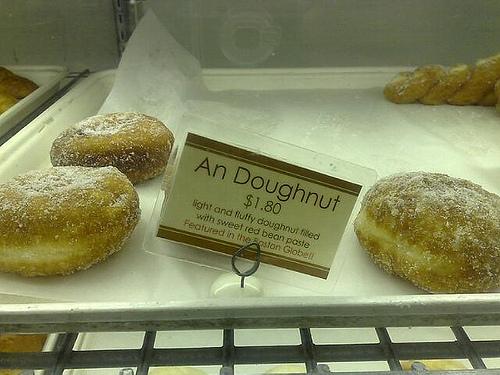How much do the donuts cost?
Give a very brief answer. $1.80. What language is the sign in front of the food items?
Give a very brief answer. English. How large are the donuts?
Answer briefly. Medium. Is this a normal doughnut?
Short answer required. No. 